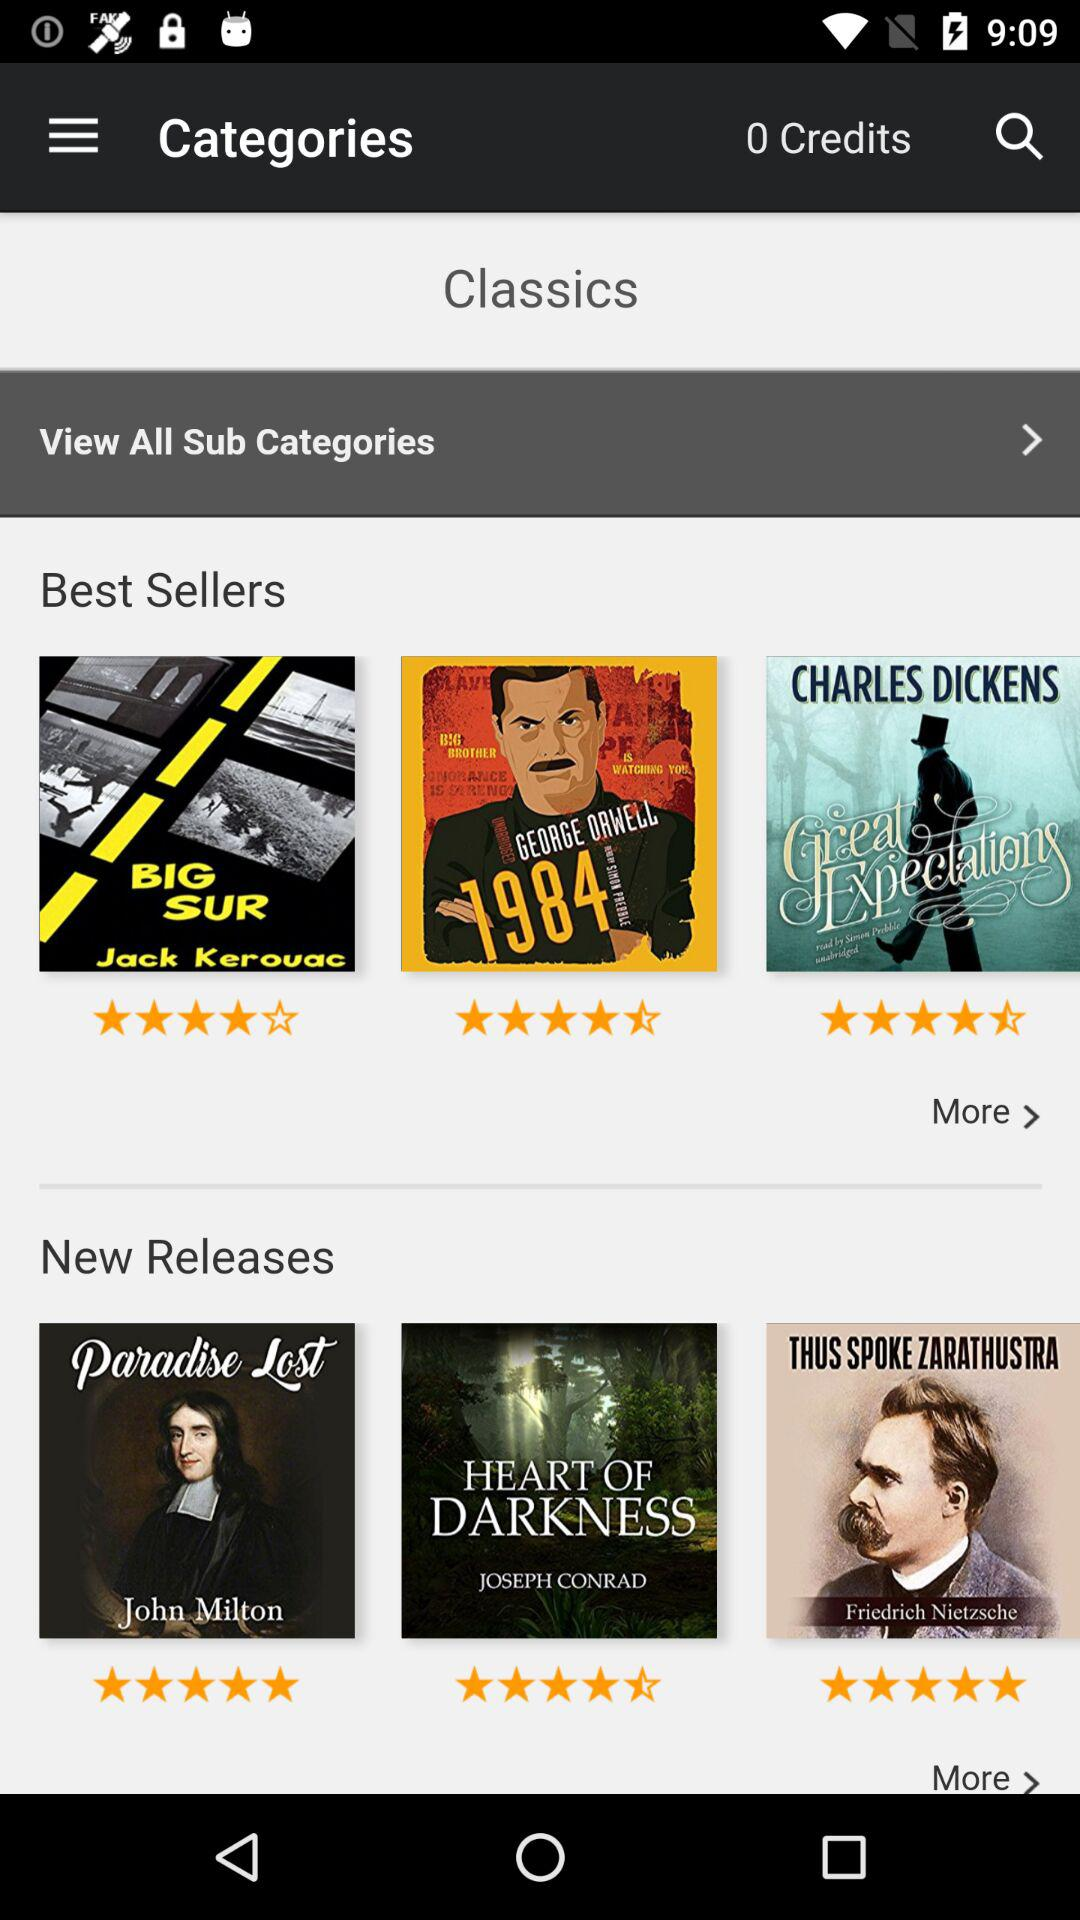How many books are in the New Releases section?
Answer the question using a single word or phrase. 3 